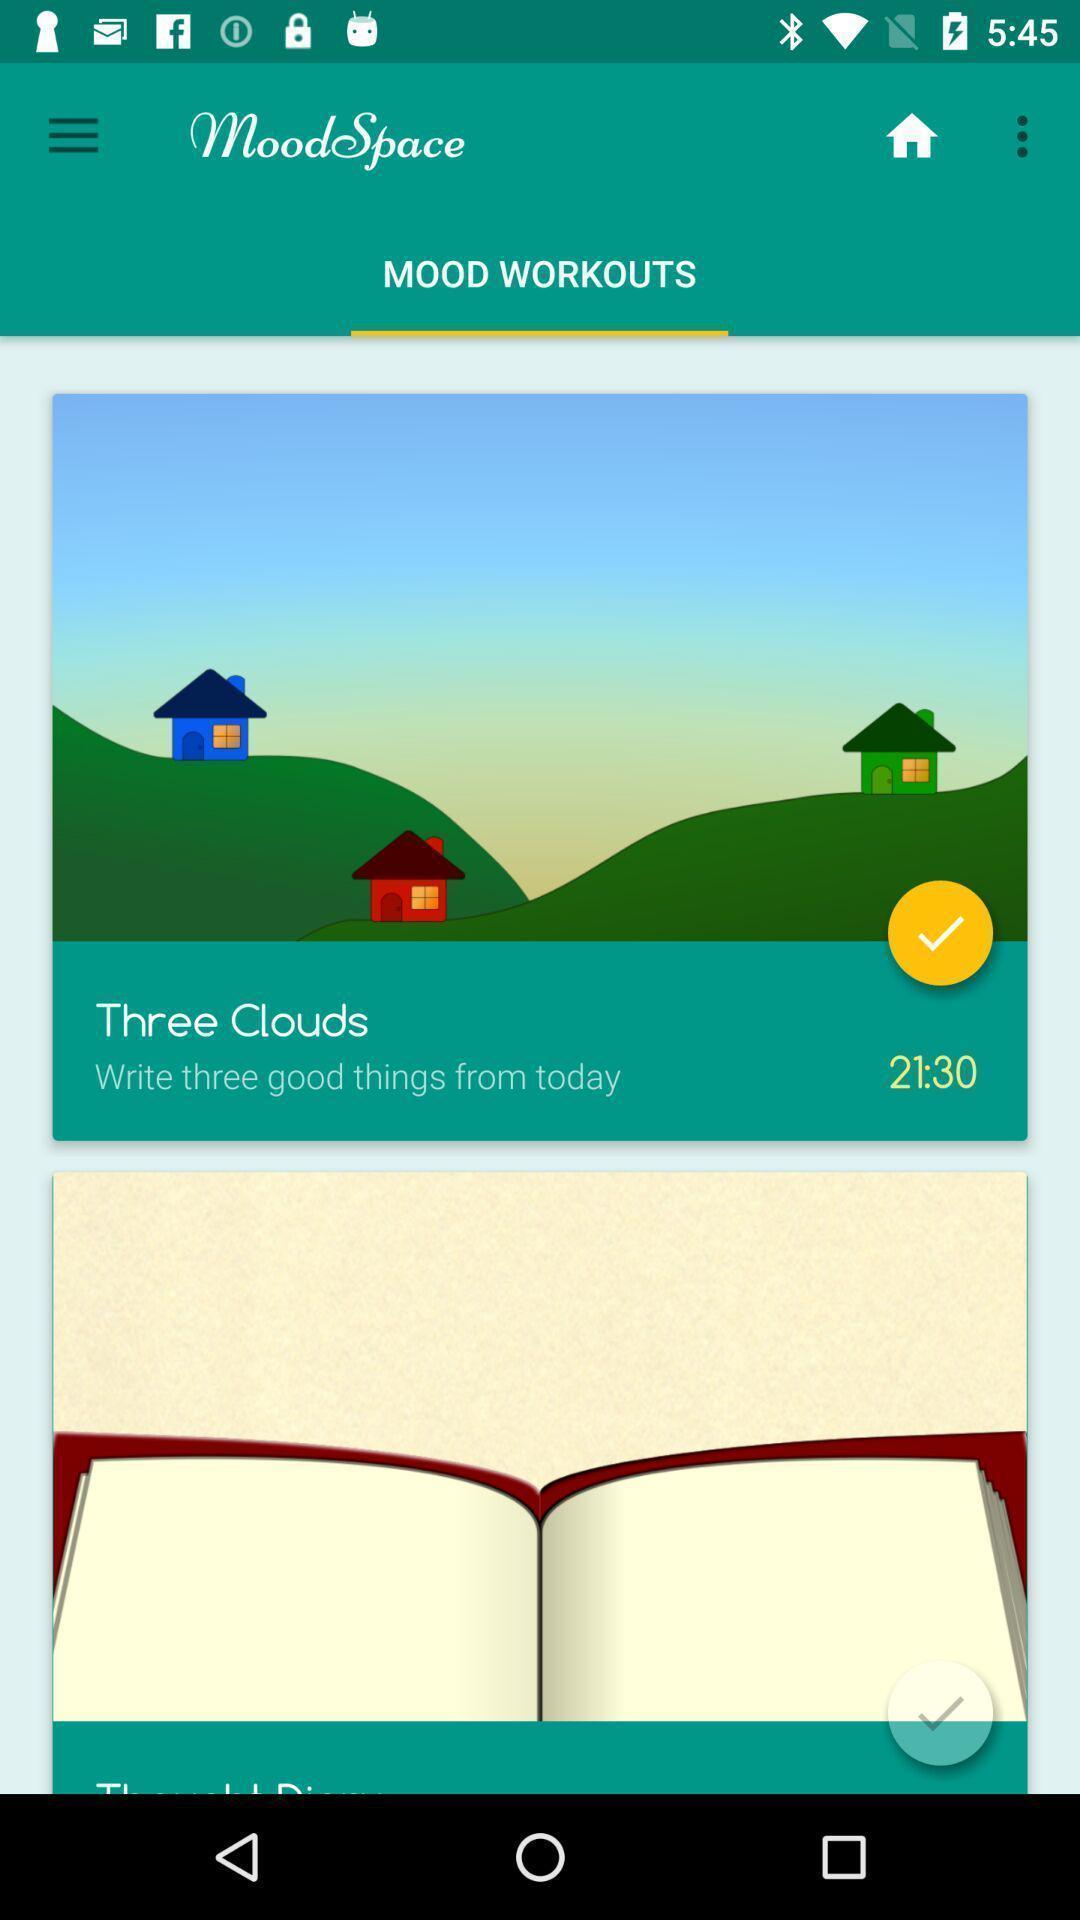What details can you identify in this image? Screen showing mood workouts. 